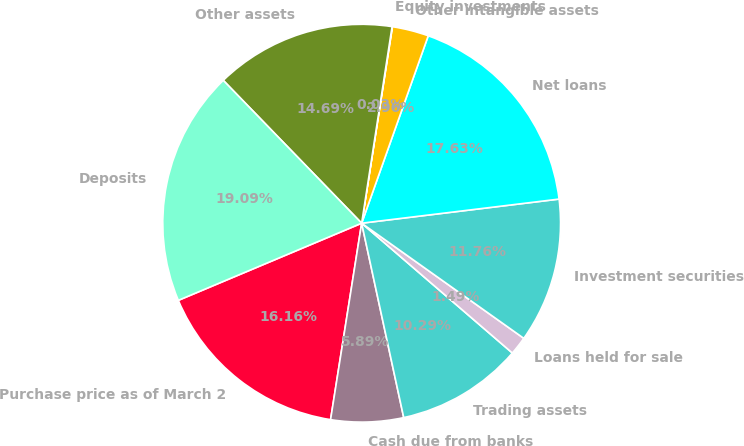<chart> <loc_0><loc_0><loc_500><loc_500><pie_chart><fcel>Purchase price as of March 2<fcel>Cash due from banks<fcel>Trading assets<fcel>Loans held for sale<fcel>Investment securities<fcel>Net loans<fcel>Other intangible assets<fcel>Equity investments<fcel>Other assets<fcel>Deposits<nl><fcel>16.16%<fcel>5.89%<fcel>10.29%<fcel>1.49%<fcel>11.76%<fcel>17.63%<fcel>2.96%<fcel>0.03%<fcel>14.69%<fcel>19.09%<nl></chart> 